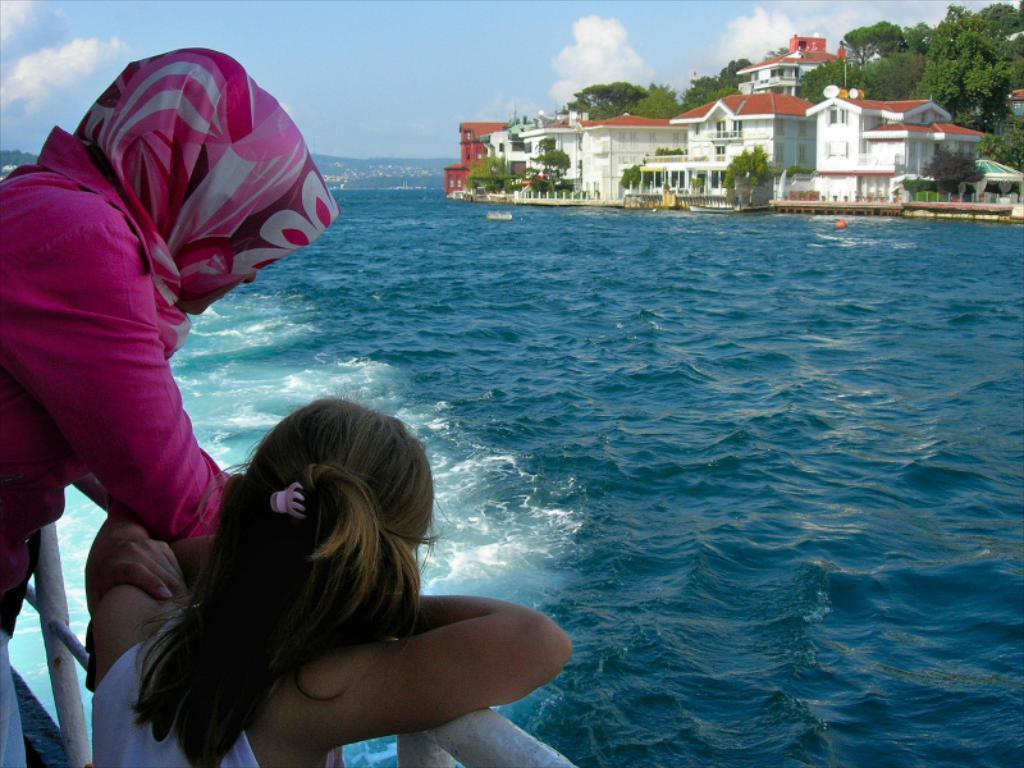Describe this image in one or two sentences. In this image in the center there are persons standing on the left side. On the right side there are buildings, trees, and the sky is cloudy. There is water in the center. 